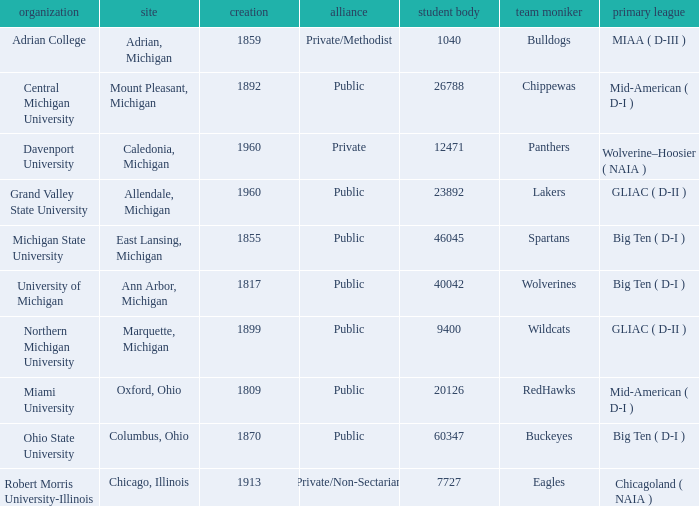What is the nickname of the Adrian, Michigan team? Bulldogs. Would you be able to parse every entry in this table? {'header': ['organization', 'site', 'creation', 'alliance', 'student body', 'team moniker', 'primary league'], 'rows': [['Adrian College', 'Adrian, Michigan', '1859', 'Private/Methodist', '1040', 'Bulldogs', 'MIAA ( D-III )'], ['Central Michigan University', 'Mount Pleasant, Michigan', '1892', 'Public', '26788', 'Chippewas', 'Mid-American ( D-I )'], ['Davenport University', 'Caledonia, Michigan', '1960', 'Private', '12471', 'Panthers', 'Wolverine–Hoosier ( NAIA )'], ['Grand Valley State University', 'Allendale, Michigan', '1960', 'Public', '23892', 'Lakers', 'GLIAC ( D-II )'], ['Michigan State University', 'East Lansing, Michigan', '1855', 'Public', '46045', 'Spartans', 'Big Ten ( D-I )'], ['University of Michigan', 'Ann Arbor, Michigan', '1817', 'Public', '40042', 'Wolverines', 'Big Ten ( D-I )'], ['Northern Michigan University', 'Marquette, Michigan', '1899', 'Public', '9400', 'Wildcats', 'GLIAC ( D-II )'], ['Miami University', 'Oxford, Ohio', '1809', 'Public', '20126', 'RedHawks', 'Mid-American ( D-I )'], ['Ohio State University', 'Columbus, Ohio', '1870', 'Public', '60347', 'Buckeyes', 'Big Ten ( D-I )'], ['Robert Morris University-Illinois', 'Chicago, Illinois', '1913', 'Private/Non-Sectarian', '7727', 'Eagles', 'Chicagoland ( NAIA )']]} 